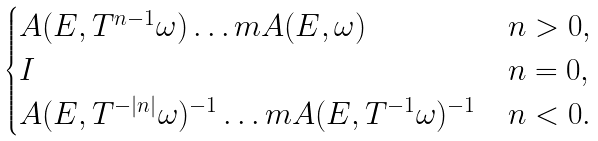Convert formula to latex. <formula><loc_0><loc_0><loc_500><loc_500>\begin{cases} A ( E , T ^ { n - 1 } \omega ) \dots m A ( E , \omega ) & n > 0 , \\ I & n = 0 , \\ A ( E , T ^ { - | n | } \omega ) ^ { - 1 } \dots m A ( E , T ^ { - 1 } \omega ) ^ { - 1 } & n < 0 . \end{cases}</formula> 